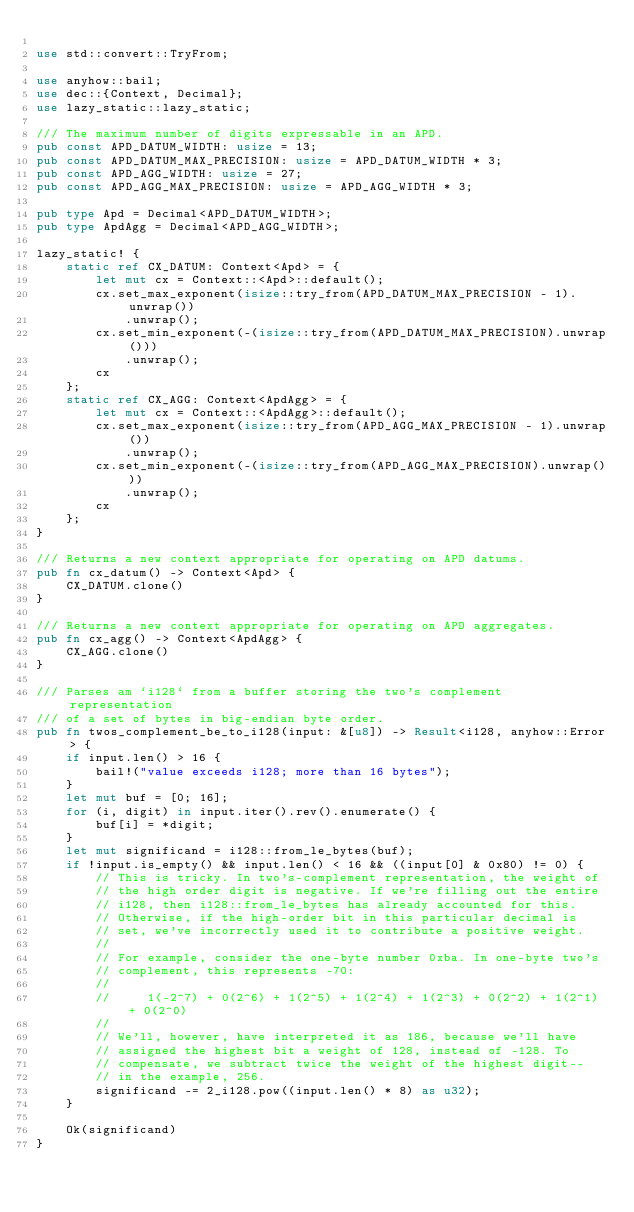<code> <loc_0><loc_0><loc_500><loc_500><_Rust_>
use std::convert::TryFrom;

use anyhow::bail;
use dec::{Context, Decimal};
use lazy_static::lazy_static;

/// The maximum number of digits expressable in an APD.
pub const APD_DATUM_WIDTH: usize = 13;
pub const APD_DATUM_MAX_PRECISION: usize = APD_DATUM_WIDTH * 3;
pub const APD_AGG_WIDTH: usize = 27;
pub const APD_AGG_MAX_PRECISION: usize = APD_AGG_WIDTH * 3;

pub type Apd = Decimal<APD_DATUM_WIDTH>;
pub type ApdAgg = Decimal<APD_AGG_WIDTH>;

lazy_static! {
    static ref CX_DATUM: Context<Apd> = {
        let mut cx = Context::<Apd>::default();
        cx.set_max_exponent(isize::try_from(APD_DATUM_MAX_PRECISION - 1).unwrap())
            .unwrap();
        cx.set_min_exponent(-(isize::try_from(APD_DATUM_MAX_PRECISION).unwrap()))
            .unwrap();
        cx
    };
    static ref CX_AGG: Context<ApdAgg> = {
        let mut cx = Context::<ApdAgg>::default();
        cx.set_max_exponent(isize::try_from(APD_AGG_MAX_PRECISION - 1).unwrap())
            .unwrap();
        cx.set_min_exponent(-(isize::try_from(APD_AGG_MAX_PRECISION).unwrap()))
            .unwrap();
        cx
    };
}

/// Returns a new context appropriate for operating on APD datums.
pub fn cx_datum() -> Context<Apd> {
    CX_DATUM.clone()
}

/// Returns a new context appropriate for operating on APD aggregates.
pub fn cx_agg() -> Context<ApdAgg> {
    CX_AGG.clone()
}

/// Parses am `i128` from a buffer storing the two's complement representation
/// of a set of bytes in big-endian byte order.
pub fn twos_complement_be_to_i128(input: &[u8]) -> Result<i128, anyhow::Error> {
    if input.len() > 16 {
        bail!("value exceeds i128; more than 16 bytes");
    }
    let mut buf = [0; 16];
    for (i, digit) in input.iter().rev().enumerate() {
        buf[i] = *digit;
    }
    let mut significand = i128::from_le_bytes(buf);
    if !input.is_empty() && input.len() < 16 && ((input[0] & 0x80) != 0) {
        // This is tricky. In two's-complement representation, the weight of
        // the high order digit is negative. If we're filling out the entire
        // i128, then i128::from_le_bytes has already accounted for this.
        // Otherwise, if the high-order bit in this particular decimal is
        // set, we've incorrectly used it to contribute a positive weight.
        //
        // For example, consider the one-byte number 0xba. In one-byte two's
        // complement, this represents -70:
        //
        //     1(-2^7) + 0(2^6) + 1(2^5) + 1(2^4) + 1(2^3) + 0(2^2) + 1(2^1) + 0(2^0)
        //
        // We'll, however, have interpreted it as 186, because we'll have
        // assigned the highest bit a weight of 128, instead of -128. To
        // compensate, we subtract twice the weight of the highest digit--
        // in the example, 256.
        significand -= 2_i128.pow((input.len() * 8) as u32);
    }

    Ok(significand)
}
</code> 